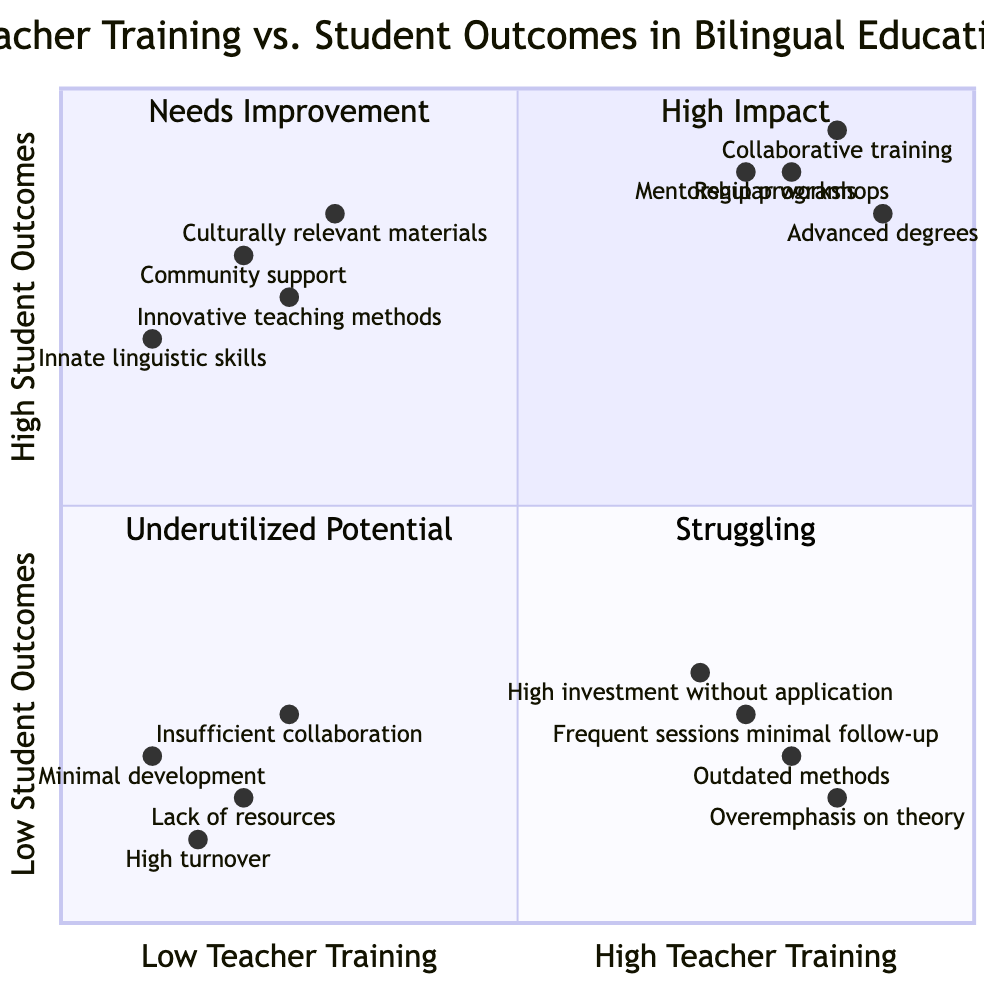What are the training practices listed in the "High Teacher Training - High Student Outcomes" quadrant? This quadrant includes practices like regular workshops by expert bilingual educators, advanced degrees in bilingual education for teachers, collaborative training with successful dual language schools, and mentorship programs connecting new and experienced bilingual teachers.
Answer: Regular workshops, advanced degrees, collaborative training, mentorship programs What is the outcome level for "High investment in professional development without practical application"? This practice is located in the "High Teacher Training - Low Student Outcomes" quadrant, indicating it results in a low level of student outcomes despite high teacher training.
Answer: Low Student Outcomes Which quadrant has the highest teacher training and highest student outcomes? This is clearly marked as the "High Impact" quadrant in the diagram.
Answer: High Impact How many practices are mentioned in the "Low Teacher Training - Low Student Outcomes" quadrant? There are four practices listed in this quadrant: minimal professional development opportunities, lack of access to up-to-date bilingual education resources, high teacher turnover rates, and insufficient collaboration among teachers and administrators.
Answer: Four What is common among all practices in the "Low Teacher Training - High Student Outcomes" quadrant? All these practices emphasize factors outside of direct teacher training, such as strong community support, culturally relevant materials, innate linguistic skills, and innovative methods that develop organically.
Answer: Community support, relevant materials, innate skills, innovative methods Which practice exhibits the lowest student outcomes among high teacher training initiatives? Among the listed practices under "High Teacher Training - Low Student Outcomes," the practice indicating the lowest student outcomes is the "Overemphasis on theory, ignoring classroom realities."
Answer: Overemphasis on theory 